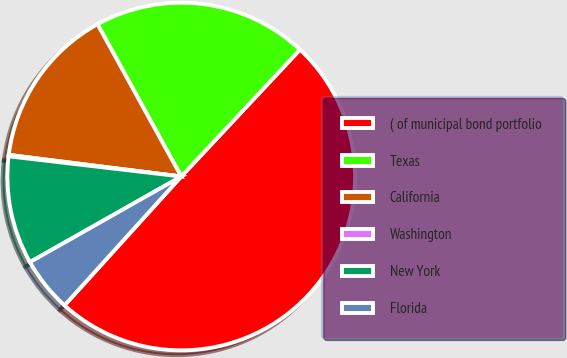Convert chart to OTSL. <chart><loc_0><loc_0><loc_500><loc_500><pie_chart><fcel>( of municipal bond portfolio<fcel>Texas<fcel>California<fcel>Washington<fcel>New York<fcel>Florida<nl><fcel>49.73%<fcel>19.97%<fcel>15.01%<fcel>0.13%<fcel>10.05%<fcel>5.09%<nl></chart> 